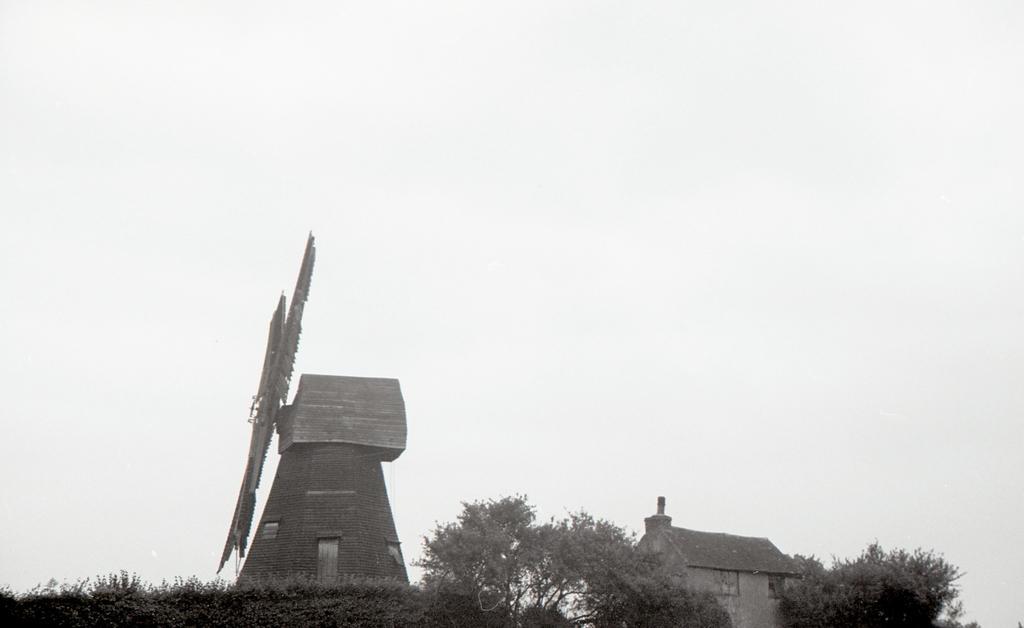Can you describe this image briefly? In this image I can see many trees, house and the windmill. In the background I can see the sky. 